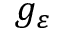Convert formula to latex. <formula><loc_0><loc_0><loc_500><loc_500>g _ { \varepsilon }</formula> 